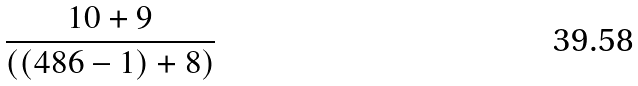<formula> <loc_0><loc_0><loc_500><loc_500>\frac { 1 0 + 9 } { ( ( 4 8 6 - 1 ) + 8 ) }</formula> 